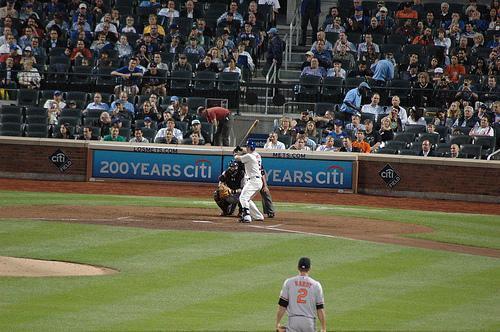How many players are on the field?
Give a very brief answer. 2. 